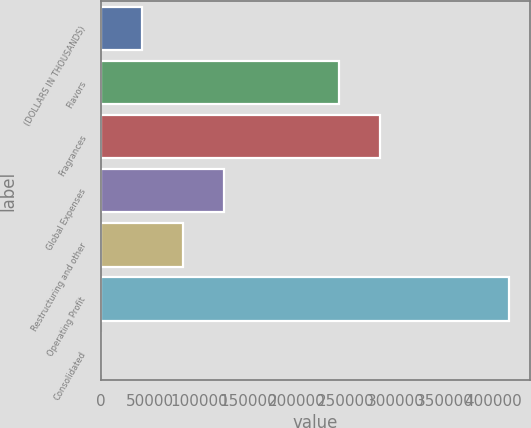Convert chart to OTSL. <chart><loc_0><loc_0><loc_500><loc_500><bar_chart><fcel>(DOLLARS IN THOUSANDS)<fcel>Flavors<fcel>Fragrances<fcel>Global Expenses<fcel>Restructuring and other<fcel>Operating Profit<fcel>Consolidated<nl><fcel>41650.4<fcel>242528<fcel>284163<fcel>124919<fcel>83284.9<fcel>416361<fcel>15.9<nl></chart> 